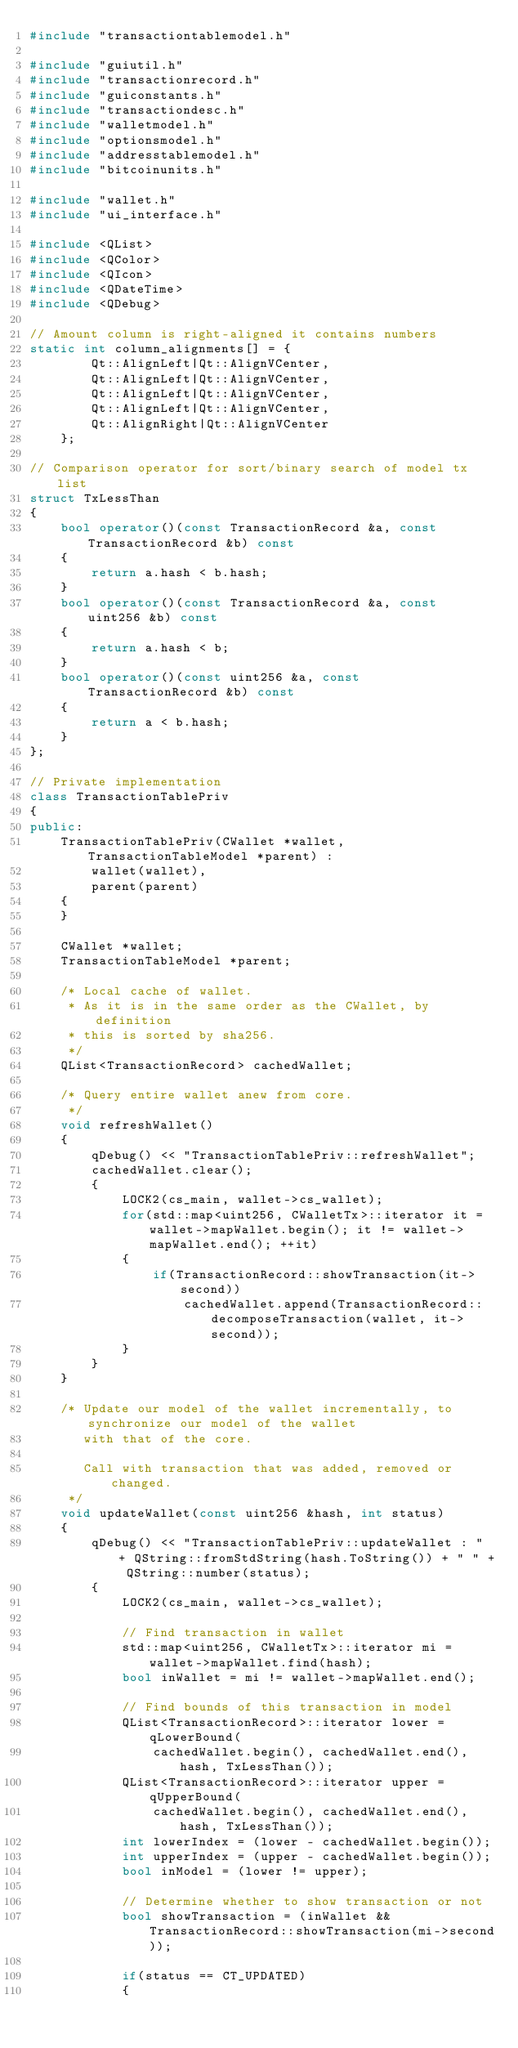Convert code to text. <code><loc_0><loc_0><loc_500><loc_500><_C++_>#include "transactiontablemodel.h"

#include "guiutil.h"
#include "transactionrecord.h"
#include "guiconstants.h"
#include "transactiondesc.h"
#include "walletmodel.h"
#include "optionsmodel.h"
#include "addresstablemodel.h"
#include "bitcoinunits.h"

#include "wallet.h"
#include "ui_interface.h"

#include <QList>
#include <QColor>
#include <QIcon>
#include <QDateTime>
#include <QDebug>

// Amount column is right-aligned it contains numbers
static int column_alignments[] = {
        Qt::AlignLeft|Qt::AlignVCenter,
        Qt::AlignLeft|Qt::AlignVCenter,
        Qt::AlignLeft|Qt::AlignVCenter,
        Qt::AlignLeft|Qt::AlignVCenter,
        Qt::AlignRight|Qt::AlignVCenter
    };

// Comparison operator for sort/binary search of model tx list
struct TxLessThan
{
    bool operator()(const TransactionRecord &a, const TransactionRecord &b) const
    {
        return a.hash < b.hash;
    }
    bool operator()(const TransactionRecord &a, const uint256 &b) const
    {
        return a.hash < b;
    }
    bool operator()(const uint256 &a, const TransactionRecord &b) const
    {
        return a < b.hash;
    }
};

// Private implementation
class TransactionTablePriv
{
public:
    TransactionTablePriv(CWallet *wallet, TransactionTableModel *parent) :
        wallet(wallet),
        parent(parent)
    {
    }

    CWallet *wallet;
    TransactionTableModel *parent;

    /* Local cache of wallet.
     * As it is in the same order as the CWallet, by definition
     * this is sorted by sha256.
     */
    QList<TransactionRecord> cachedWallet;

    /* Query entire wallet anew from core.
     */
    void refreshWallet()
    {
        qDebug() << "TransactionTablePriv::refreshWallet";
        cachedWallet.clear();
        {
            LOCK2(cs_main, wallet->cs_wallet);
            for(std::map<uint256, CWalletTx>::iterator it = wallet->mapWallet.begin(); it != wallet->mapWallet.end(); ++it)
            {
                if(TransactionRecord::showTransaction(it->second))
                    cachedWallet.append(TransactionRecord::decomposeTransaction(wallet, it->second));
            }
        }
    }

    /* Update our model of the wallet incrementally, to synchronize our model of the wallet
       with that of the core.

       Call with transaction that was added, removed or changed.
     */
    void updateWallet(const uint256 &hash, int status)
    {
        qDebug() << "TransactionTablePriv::updateWallet : " + QString::fromStdString(hash.ToString()) + " " + QString::number(status);
        {
            LOCK2(cs_main, wallet->cs_wallet);

            // Find transaction in wallet
            std::map<uint256, CWalletTx>::iterator mi = wallet->mapWallet.find(hash);
            bool inWallet = mi != wallet->mapWallet.end();

            // Find bounds of this transaction in model
            QList<TransactionRecord>::iterator lower = qLowerBound(
                cachedWallet.begin(), cachedWallet.end(), hash, TxLessThan());
            QList<TransactionRecord>::iterator upper = qUpperBound(
                cachedWallet.begin(), cachedWallet.end(), hash, TxLessThan());
            int lowerIndex = (lower - cachedWallet.begin());
            int upperIndex = (upper - cachedWallet.begin());
            bool inModel = (lower != upper);

            // Determine whether to show transaction or not
            bool showTransaction = (inWallet && TransactionRecord::showTransaction(mi->second));

            if(status == CT_UPDATED)
            {</code> 